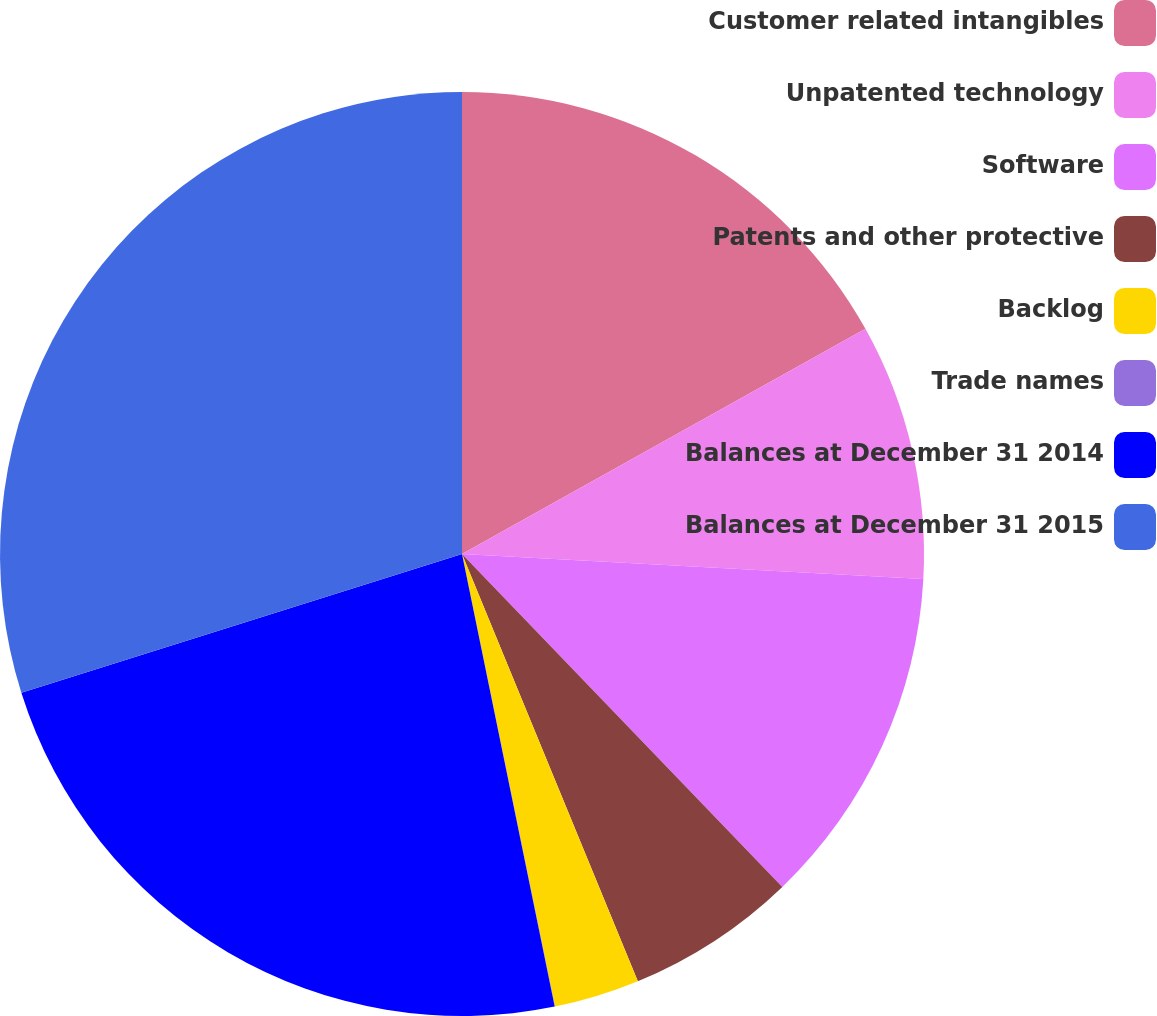<chart> <loc_0><loc_0><loc_500><loc_500><pie_chart><fcel>Customer related intangibles<fcel>Unpatented technology<fcel>Software<fcel>Patents and other protective<fcel>Backlog<fcel>Trade names<fcel>Balances at December 31 2014<fcel>Balances at December 31 2015<nl><fcel>16.9%<fcel>8.96%<fcel>11.95%<fcel>5.98%<fcel>2.99%<fcel>0.01%<fcel>23.36%<fcel>29.86%<nl></chart> 